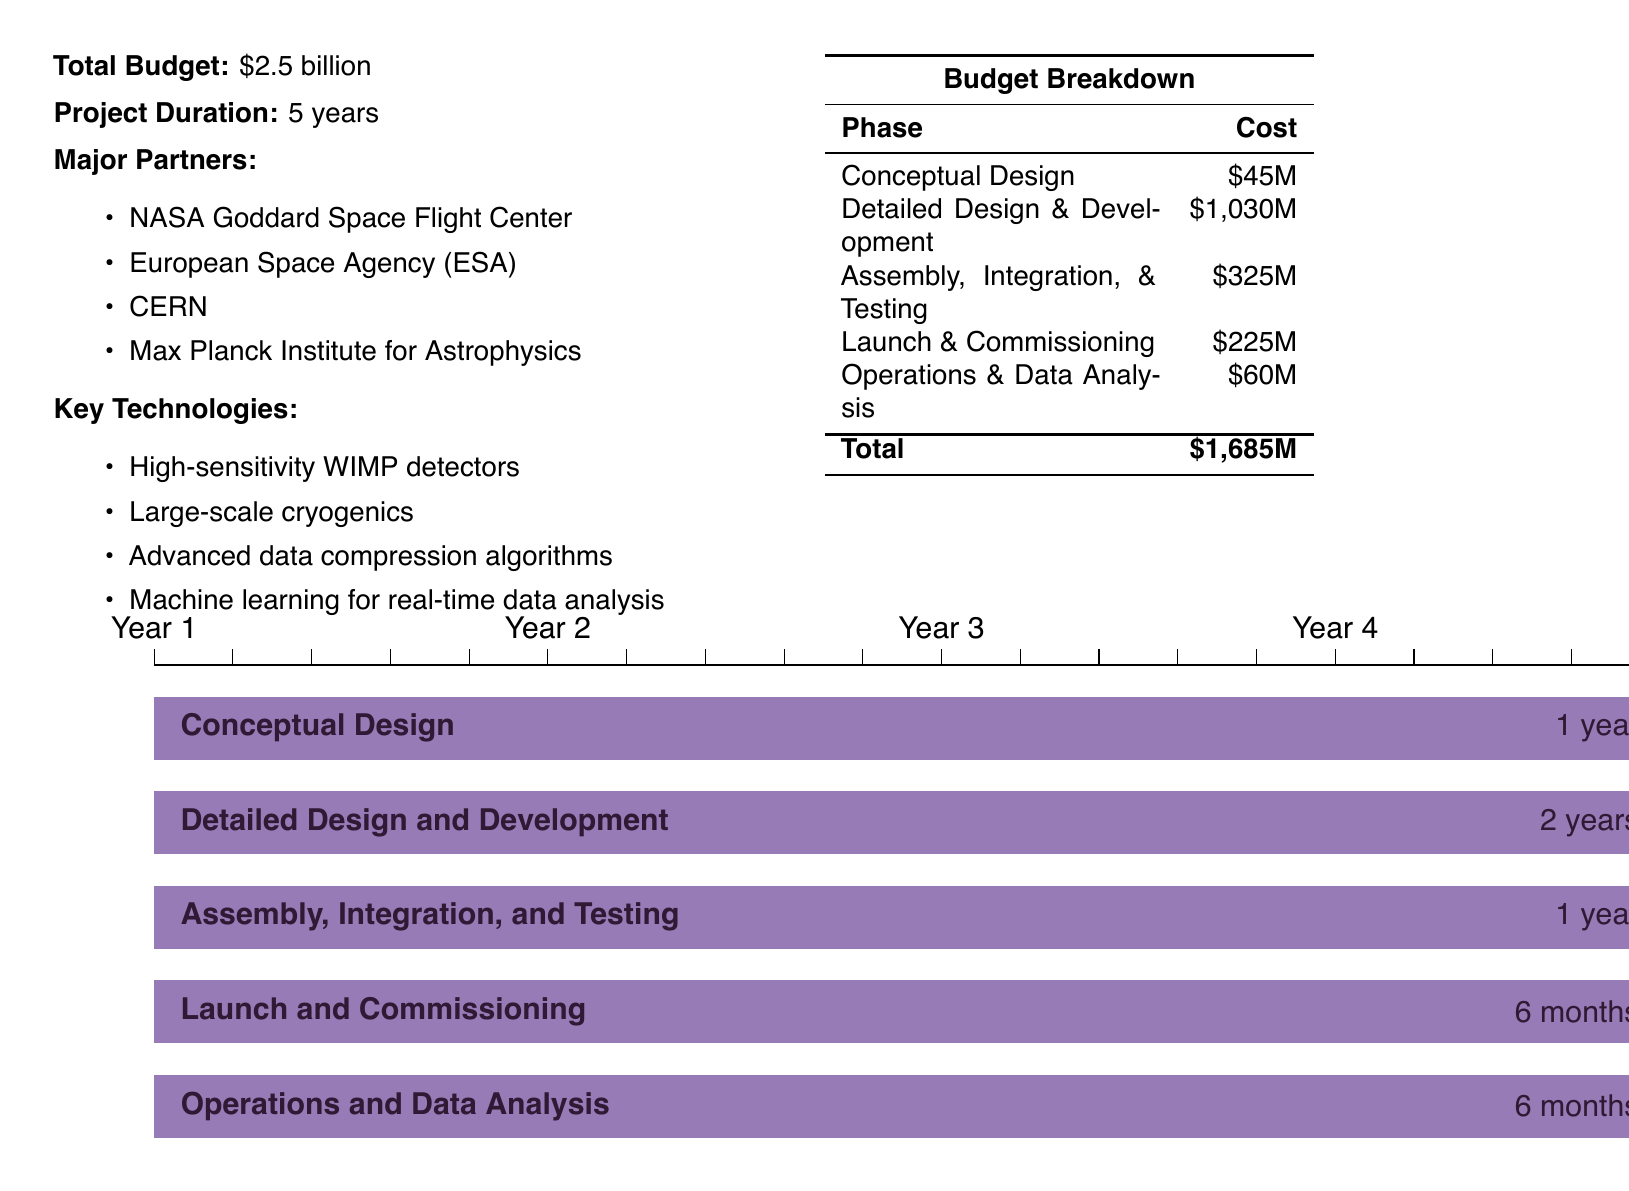What is the total budget? The total budget is explicitly stated in the document as $2.5 billion.
Answer: $2.5 billion How much is allocated for the Detailed Design & Development phase? The cost for Detailed Design & Development can be found in the budget breakdown table, which shows it as $1,030M.
Answer: $1,030M Who are the major partners in this project? The document lists major partners including NASA Goddard Space Flight Center, European Space Agency, CERN, and Max Planck Institute for Astrophysics.
Answer: NASA Goddard Space Flight Center, European Space Agency, CERN, Max Planck Institute for Astrophysics What technology is used for real-time data analysis? The document states that machine learning is used for real-time data analysis among key technologies.
Answer: Machine learning How long is the Assembly, Integration, & Testing phase? The phase durations are indicated in the timeline section; Assembly, Integration, & Testing lasts for 1 year.
Answer: 1 year What percentage of the total budget is spent on Operations & Data Analysis? To find the percentage, take the cost of Operations & Data Analysis ($60M) divided by the total budget ($2.5 billion) and multiply by 100.
Answer: 2.4% Which phase has the lowest budget allocation? The budget breakdown table shows that the Conceptual Design phase has the lowest allocation at $45M.
Answer: $45M How many years is the project duration? The project duration is specified in the document as 5 years.
Answer: 5 years What is the cost for Launch & Commissioning? The budget breakdown lists the cost for Launch & Commissioning as $225M.
Answer: $225M 